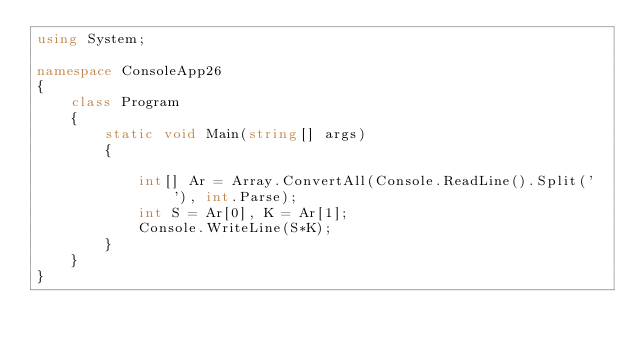Convert code to text. <code><loc_0><loc_0><loc_500><loc_500><_C#_>using System;

namespace ConsoleApp26
{
    class Program
    {
        static void Main(string[] args)
        {

            int[] Ar = Array.ConvertAll(Console.ReadLine().Split(' '), int.Parse);
            int S = Ar[0], K = Ar[1];
            Console.WriteLine(S*K);
        }
    }
}
</code> 